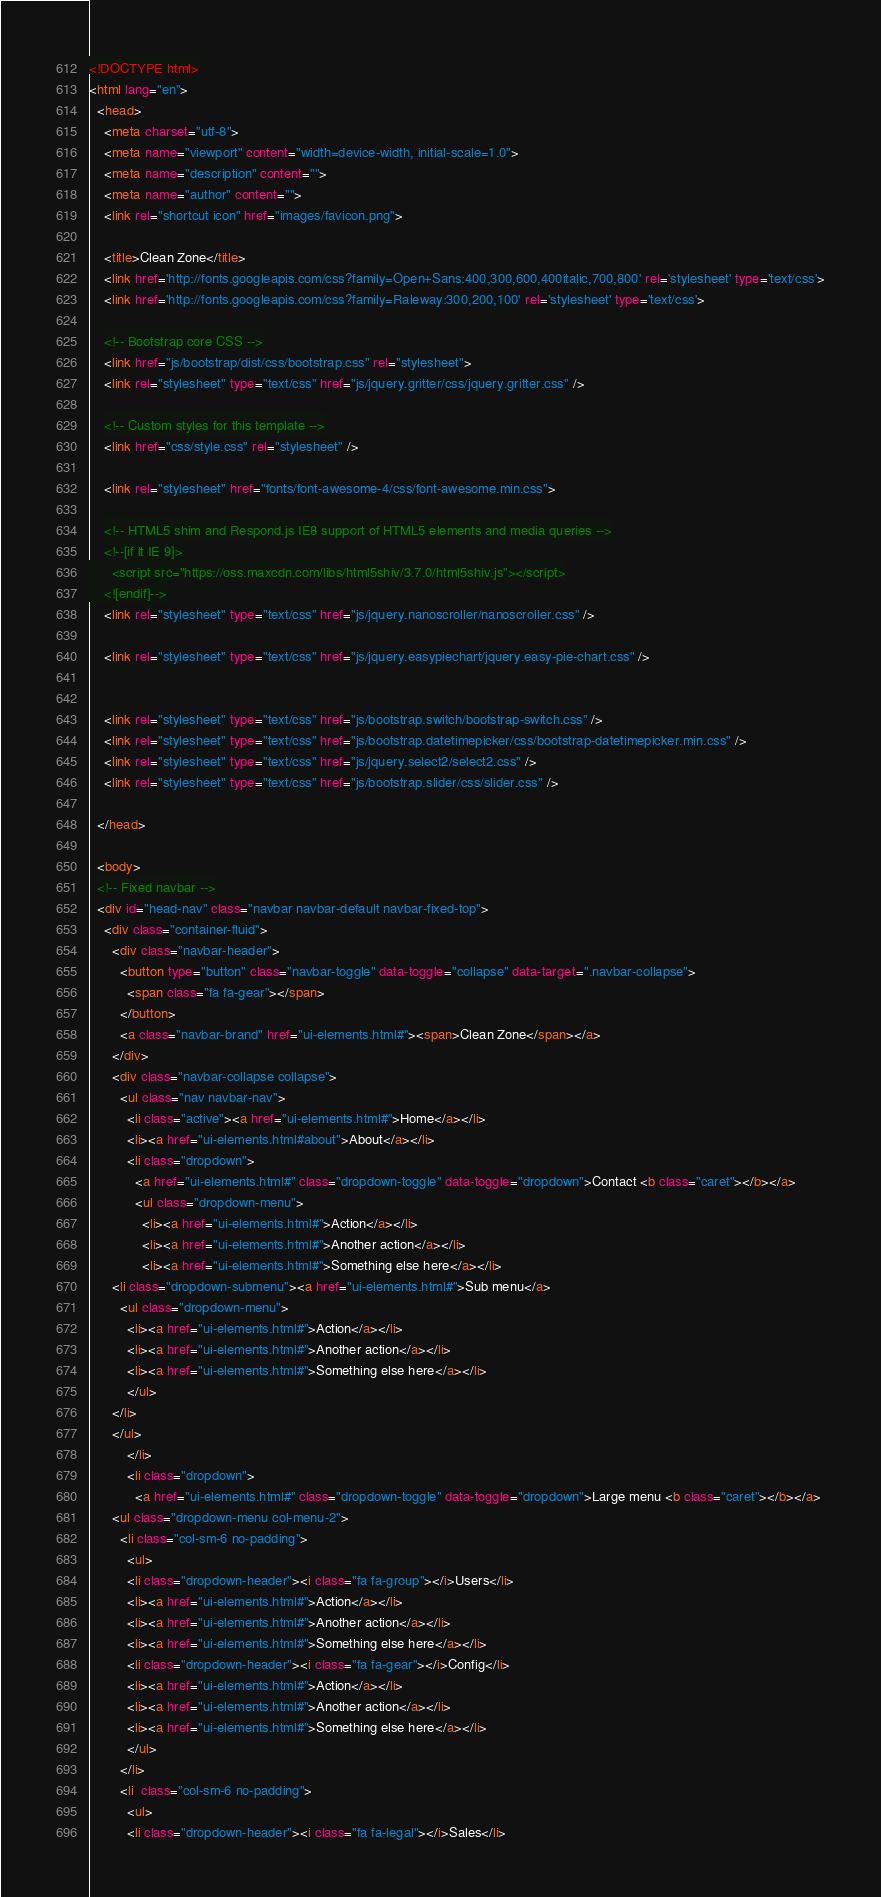<code> <loc_0><loc_0><loc_500><loc_500><_HTML_><!DOCTYPE html>
<html lang="en">
  <head>
    <meta charset="utf-8">
    <meta name="viewport" content="width=device-width, initial-scale=1.0">
    <meta name="description" content="">
    <meta name="author" content="">
    <link rel="shortcut icon" href="images/favicon.png">

    <title>Clean Zone</title>
    <link href='http://fonts.googleapis.com/css?family=Open+Sans:400,300,600,400italic,700,800' rel='stylesheet' type='text/css'>
    <link href='http://fonts.googleapis.com/css?family=Raleway:300,200,100' rel='stylesheet' type='text/css'>

    <!-- Bootstrap core CSS -->
    <link href="js/bootstrap/dist/css/bootstrap.css" rel="stylesheet">
    <link rel="stylesheet" type="text/css" href="js/jquery.gritter/css/jquery.gritter.css" />

    <!-- Custom styles for this template -->
    <link href="css/style.css" rel="stylesheet" />

    <link rel="stylesheet" href="fonts/font-awesome-4/css/font-awesome.min.css">

    <!-- HTML5 shim and Respond.js IE8 support of HTML5 elements and media queries -->
    <!--[if lt IE 9]>
      <script src="https://oss.maxcdn.com/libs/html5shiv/3.7.0/html5shiv.js"></script>
    <![endif]-->
    <link rel="stylesheet" type="text/css" href="js/jquery.nanoscroller/nanoscroller.css" />
	
    <link rel="stylesheet" type="text/css" href="js/jquery.easypiechart/jquery.easy-pie-chart.css" />
	
	
    <link rel="stylesheet" type="text/css" href="js/bootstrap.switch/bootstrap-switch.css" />
    <link rel="stylesheet" type="text/css" href="js/bootstrap.datetimepicker/css/bootstrap-datetimepicker.min.css" />
    <link rel="stylesheet" type="text/css" href="js/jquery.select2/select2.css" />
    <link rel="stylesheet" type="text/css" href="js/bootstrap.slider/css/slider.css" />
	
  </head>

  <body>
  <!-- Fixed navbar -->
  <div id="head-nav" class="navbar navbar-default navbar-fixed-top">
    <div class="container-fluid">
      <div class="navbar-header">
        <button type="button" class="navbar-toggle" data-toggle="collapse" data-target=".navbar-collapse">
          <span class="fa fa-gear"></span>
        </button>
        <a class="navbar-brand" href="ui-elements.html#"><span>Clean Zone</span></a>
      </div>
      <div class="navbar-collapse collapse">
        <ul class="nav navbar-nav">
          <li class="active"><a href="ui-elements.html#">Home</a></li>
          <li><a href="ui-elements.html#about">About</a></li>
          <li class="dropdown">
            <a href="ui-elements.html#" class="dropdown-toggle" data-toggle="dropdown">Contact <b class="caret"></b></a>
            <ul class="dropdown-menu">
              <li><a href="ui-elements.html#">Action</a></li>
              <li><a href="ui-elements.html#">Another action</a></li>
              <li><a href="ui-elements.html#">Something else here</a></li>
      <li class="dropdown-submenu"><a href="ui-elements.html#">Sub menu</a>
        <ul class="dropdown-menu">
          <li><a href="ui-elements.html#">Action</a></li>
          <li><a href="ui-elements.html#">Another action</a></li>
          <li><a href="ui-elements.html#">Something else here</a></li>
          </ul>
      </li>              
      </ul>
          </li>
          <li class="dropdown">
            <a href="ui-elements.html#" class="dropdown-toggle" data-toggle="dropdown">Large menu <b class="caret"></b></a>
      <ul class="dropdown-menu col-menu-2">
        <li class="col-sm-6 no-padding">
          <ul>
          <li class="dropdown-header"><i class="fa fa-group"></i>Users</li>
          <li><a href="ui-elements.html#">Action</a></li>
          <li><a href="ui-elements.html#">Another action</a></li>
          <li><a href="ui-elements.html#">Something else here</a></li>
          <li class="dropdown-header"><i class="fa fa-gear"></i>Config</li>
          <li><a href="ui-elements.html#">Action</a></li>
          <li><a href="ui-elements.html#">Another action</a></li>
          <li><a href="ui-elements.html#">Something else here</a></li> 
          </ul>
        </li>
        <li  class="col-sm-6 no-padding">
          <ul>
          <li class="dropdown-header"><i class="fa fa-legal"></i>Sales</li></code> 